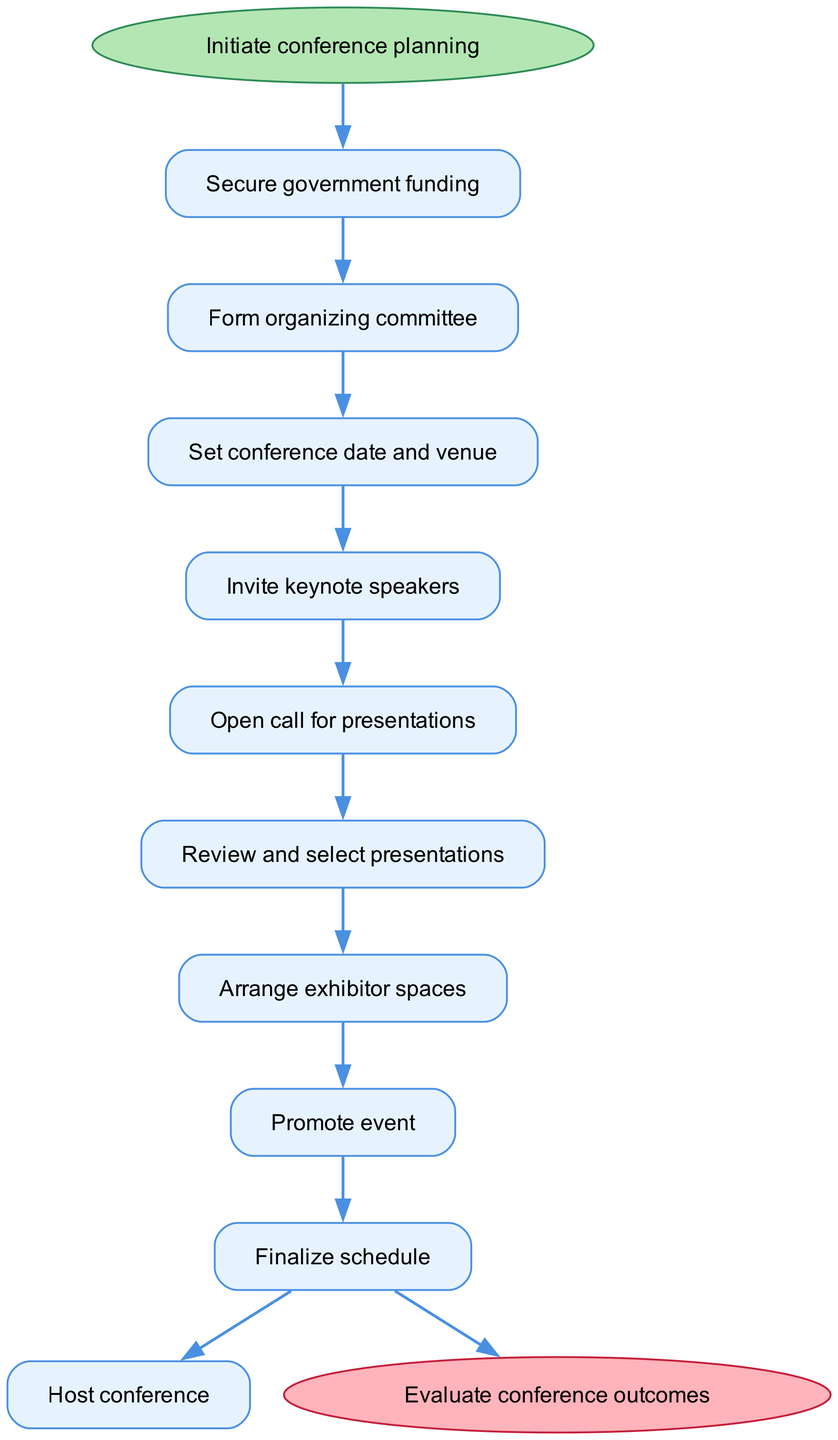What is the first step in the workflow? The first step in the workflow is indicated as the initial node that connects the start node to the next step. According to the diagram, the first step is "Secure government funding."
Answer: Secure government funding How many steps are there in total? The number of steps can be counted from the diagram, which includes each action taken in the workflow. There are nine steps listed in the workflow.
Answer: Nine Which step comes after "Open call for presentations"? By examining the flow of the diagram, the step that follows "Open call for presentations" is detailed as the next step connected to it. The following step is "Review and select presentations."
Answer: Review and select presentations What is the last stage in the workflow? The last stage in the workflow is represented by the end node that follows the final step in the process. The last stage is "Evaluate conference outcomes."
Answer: Evaluate conference outcomes What is the connection between "Secure government funding" and "Form organizing committee"? The flowchart indicates that "Secure government funding" directly leads to "Form organizing committee," reflecting a sequential relationship where one step must be completed before the next can begin.
Answer: Sequential relationship Which two steps are related to "Promote event"? By looking at the diagram, "Promote event" connects to both the preceding step "Arrange exhibitor spaces" and the succeeding step "Finalize schedule," indicating the steps that come before and after it.
Answer: Arrange exhibitor spaces and Finalize schedule What action is taken immediately before hosting the conference? The action taken right before hosting the conference can be identified by tracing back the steps leading to the last node in the workflow. The action is "Finalize schedule."
Answer: Finalize schedule How does the workflow end? The ending of the workflow can be identified by looking for the end node which follows the completion of all steps in the flow. The workflow concludes with the evaluation of the conference outcomes.
Answer: Evaluate conference outcomes 